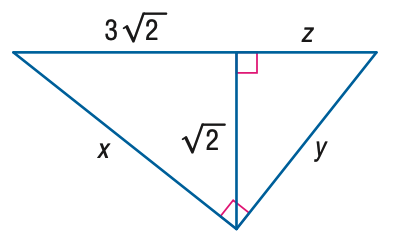Answer the mathemtical geometry problem and directly provide the correct option letter.
Question: Find z.
Choices: A: \frac { \sqrt { 2 } } { 3 } B: \frac { \sqrt { 5 } } { 3 } C: \sqrt { 2 } D: \sqrt { 5 } A 